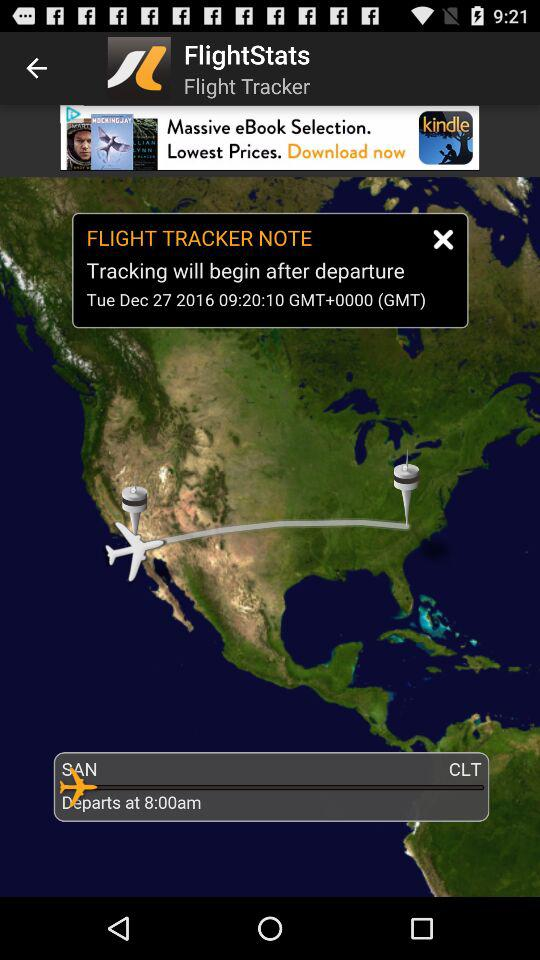What is the departure time? The departure time is 8:00 a.m. 